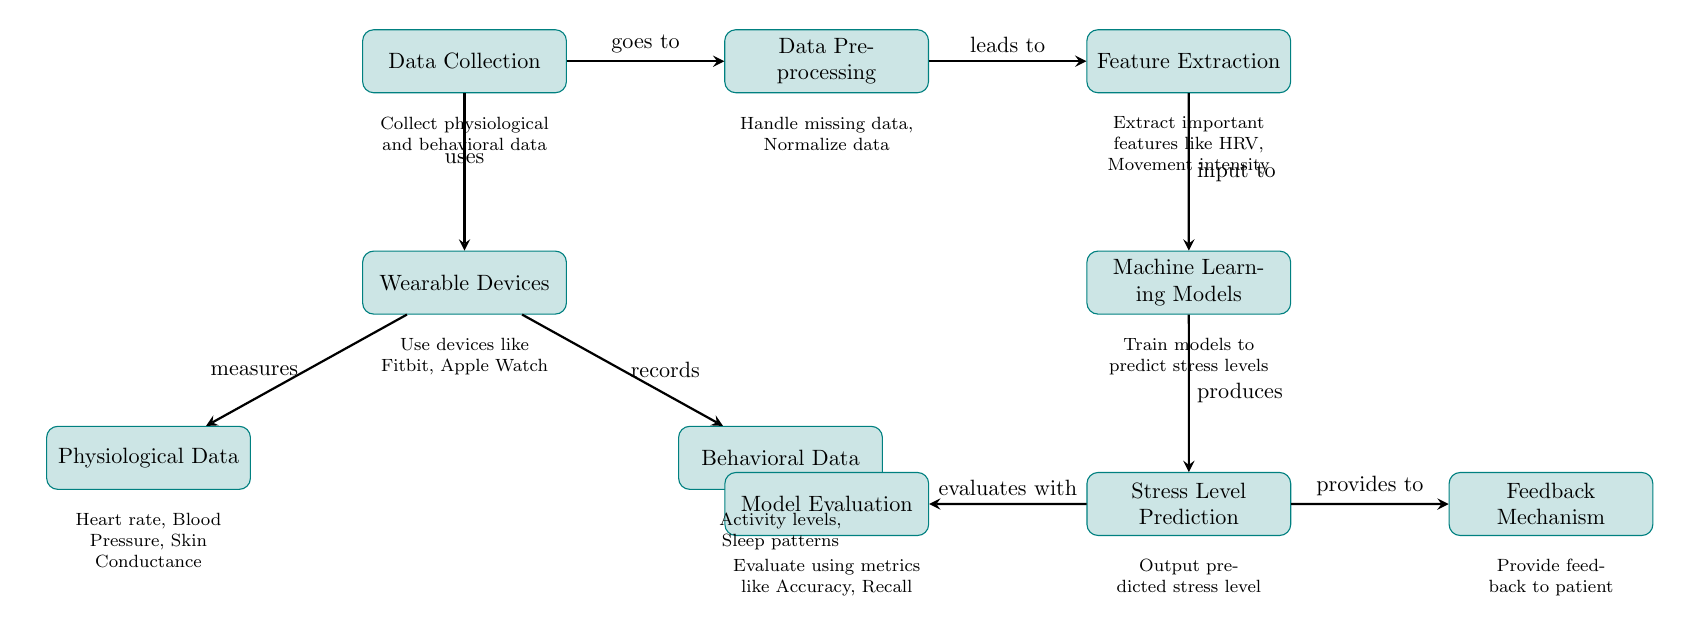What is the first process in the diagram? The first node labeled in the diagram is "Data Collection." This is determined by looking at the topmost node in the flow.
Answer: Data Collection How many types of data are collected by the wearable devices? There are two types of data shown in the diagram: Physiological Data and Behavioral Data. These are the two branches that come from the "Wearable Devices" node.
Answer: Two What do wearable devices measure? The measurement functions of wearable devices are specified in the diagram as "Physiological Data," which includes heart rate, blood pressure, and skin conductance. These metrics are detailed under the corresponding node.
Answer: Physiological Data What is the output of the "Machine Learning Models" process? The output from the "Machine Learning Models" node is described as "Stress Level Prediction," indicating that this is the result produced by the machine learning models based on the analysis of the input data.
Answer: Stress Level Prediction What process comes after "Feature Extraction"? The next process following "Feature Extraction" is "Machine Learning Models." This establishes the flow where extracted features are used as input for model training.
Answer: Machine Learning Models What does the "Feedback Mechanism" provide to the patient? The "Feedback Mechanism" node specifies that it "provides to" the stress level prediction, meaning it delivers the output back to the patient based on the model's analysis.
Answer: Provides to Which two metrics are used in "Model Evaluation"? The evaluation of the models is indicated to involve metrics called "Accuracy" and "Recall," which are stated under the node describing the process of model evaluation.
Answer: Accuracy, Recall Which node utilizes the input data from the wearable devices? The "Data Pre-processing" node uses the data collected by the "Wearable Devices." The flow of the diagram shows that the output from "Data Collection" feeds directly into "Data Pre-processing."
Answer: Data Pre-processing How many arrows are present in the diagram? By counting the arrows that connect the various processes shown in the diagram, we find there are a total of 9 arrows indicating the relationships and flow between nodes.
Answer: Nine 